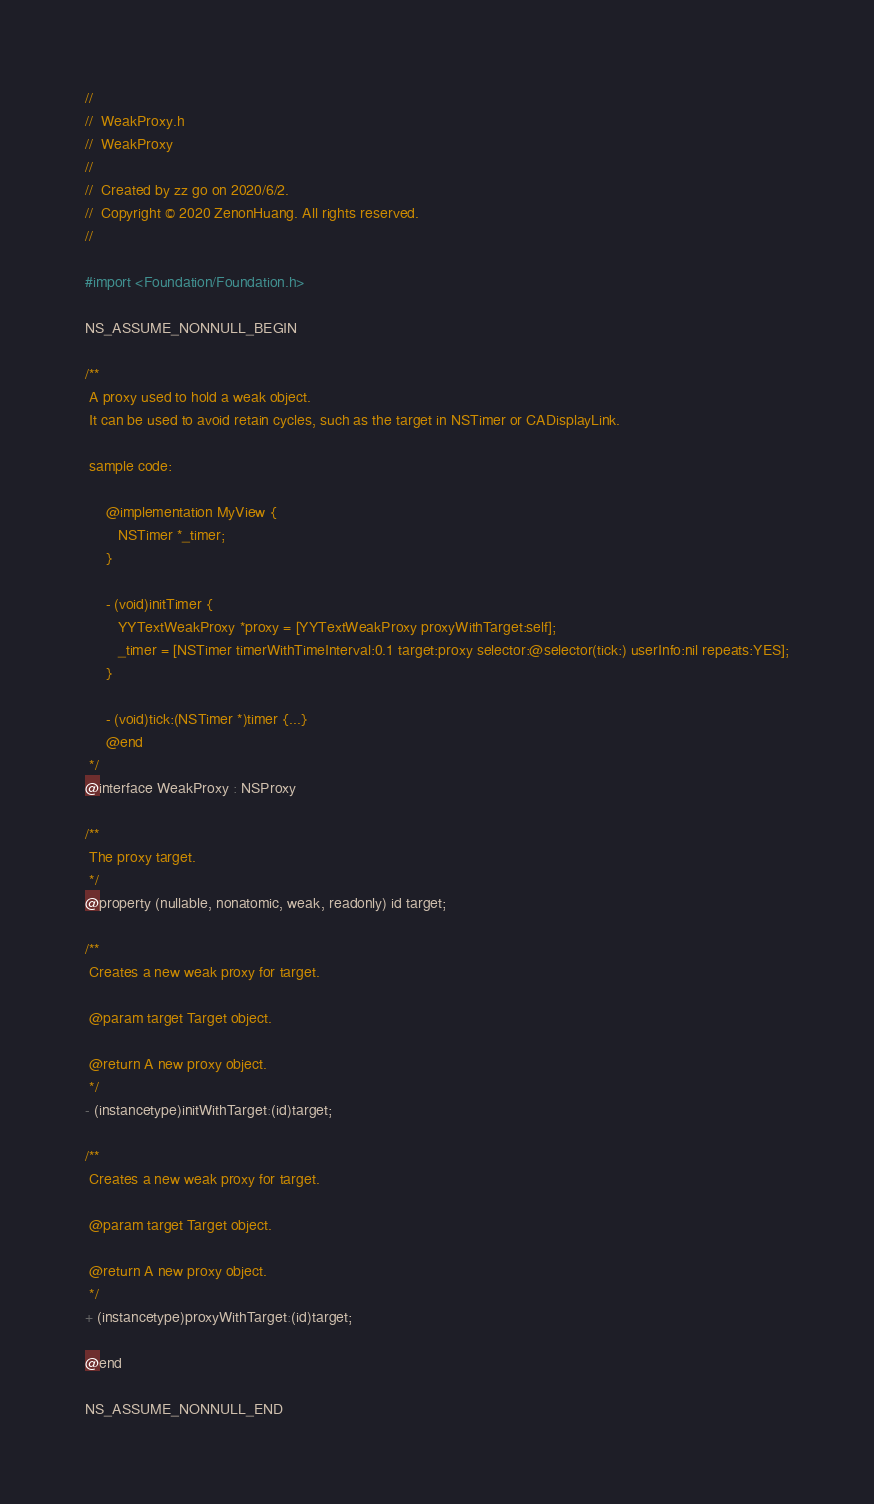<code> <loc_0><loc_0><loc_500><loc_500><_C_>//
//  WeakProxy.h
//  WeakProxy
//
//  Created by zz go on 2020/6/2.
//  Copyright © 2020 ZenonHuang. All rights reserved.
//

#import <Foundation/Foundation.h>

NS_ASSUME_NONNULL_BEGIN

/**
 A proxy used to hold a weak object.
 It can be used to avoid retain cycles, such as the target in NSTimer or CADisplayLink.
 
 sample code:
 
     @implementation MyView {
        NSTimer *_timer;
     }
     
     - (void)initTimer {
        YYTextWeakProxy *proxy = [YYTextWeakProxy proxyWithTarget:self];
        _timer = [NSTimer timerWithTimeInterval:0.1 target:proxy selector:@selector(tick:) userInfo:nil repeats:YES];
     }
     
     - (void)tick:(NSTimer *)timer {...}
     @end
 */
@interface WeakProxy : NSProxy

/**
 The proxy target.
 */
@property (nullable, nonatomic, weak, readonly) id target;

/**
 Creates a new weak proxy for target.
 
 @param target Target object.
 
 @return A new proxy object.
 */
- (instancetype)initWithTarget:(id)target;

/**
 Creates a new weak proxy for target.
 
 @param target Target object.
 
 @return A new proxy object.
 */
+ (instancetype)proxyWithTarget:(id)target;

@end

NS_ASSUME_NONNULL_END

</code> 